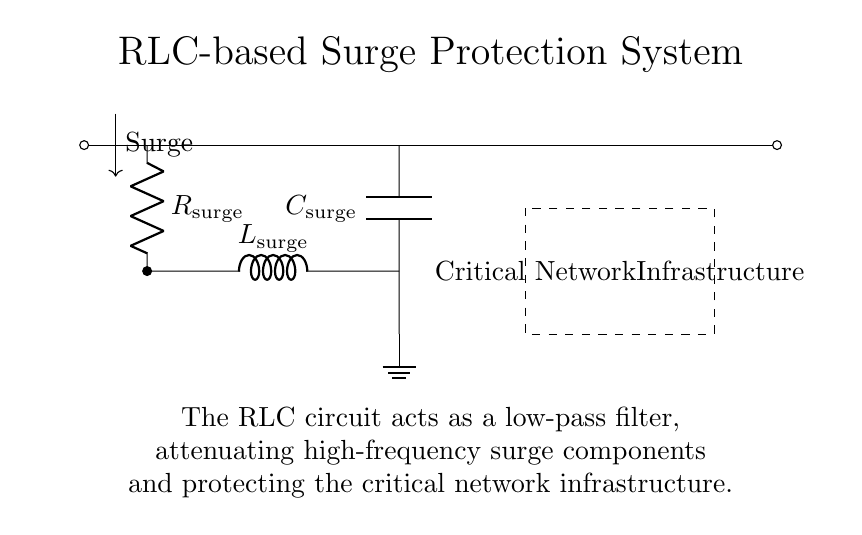What is the function of the resistor in this circuit? The resistor, labeled as surge resistor, is meant to limit the current flowing into the circuit during a surge event, thereby protecting downstream components.
Answer: limit current What type of filter does this RLC circuit represent? This RLC configuration acts as a low-pass filter, which allows low-frequency signals to pass while attenuating high-frequency surge components, crucial for protecting sensitive equipment.
Answer: low-pass filter What component is situated at the output of the RLC circuit? The capacitor is connected to the output of the inductor, which is essential in maintaining steady voltage levels during transient conditions caused by surges.
Answer: capacitor How many components are used in the RLC circuit? There are three main components used in this surge protection system: a resistor, an inductor, and a capacitor, forming the RLC configuration.
Answer: three components What is the purpose of the ground connection in this circuit? The ground connection provides a reference point for the circuit and allows any surge energy to dissipate safely into the earth, preventing damage to the critical infrastructure.
Answer: dissipation of surge energy What is the relative placement of the inductor and capacitor in the circuit? The inductor is positioned between the resistor and the capacitor, forming a series connection before the capacitor, which defines the filtering characteristics of the circuit.
Answer: in series configuration What does the dashed rectangle represent in the diagram? The dashed rectangle encloses the area that represents the critical network infrastructure, indicating the components that are being protected by the surge protection system in the circuit.
Answer: critical network infrastructure 